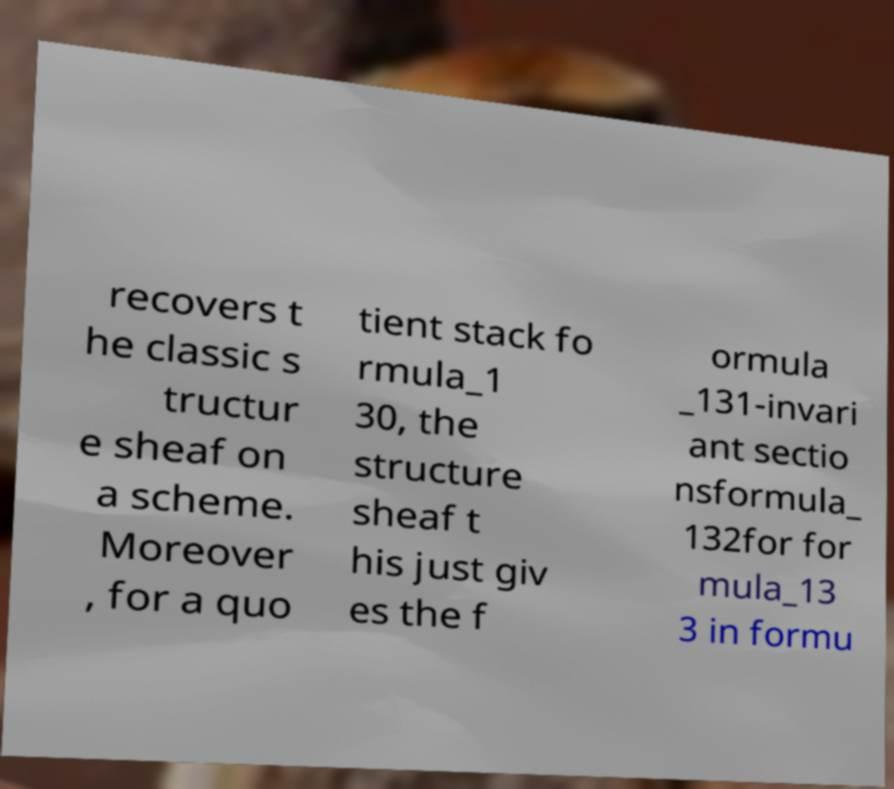Please identify and transcribe the text found in this image. recovers t he classic s tructur e sheaf on a scheme. Moreover , for a quo tient stack fo rmula_1 30, the structure sheaf t his just giv es the f ormula _131-invari ant sectio nsformula_ 132for for mula_13 3 in formu 